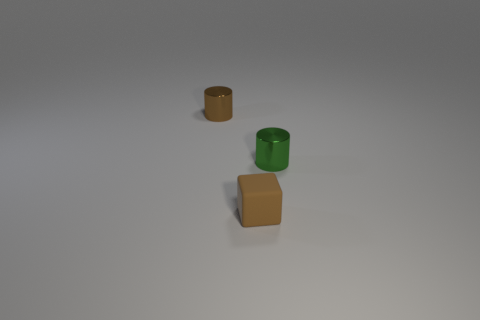Add 2 green rubber spheres. How many objects exist? 5 Subtract all cylinders. How many objects are left? 1 Add 1 tiny matte cubes. How many tiny matte cubes are left? 2 Add 3 small green metal objects. How many small green metal objects exist? 4 Subtract 1 brown cylinders. How many objects are left? 2 Subtract all gray cylinders. Subtract all purple cubes. How many cylinders are left? 2 Subtract all small green cylinders. Subtract all brown metallic things. How many objects are left? 1 